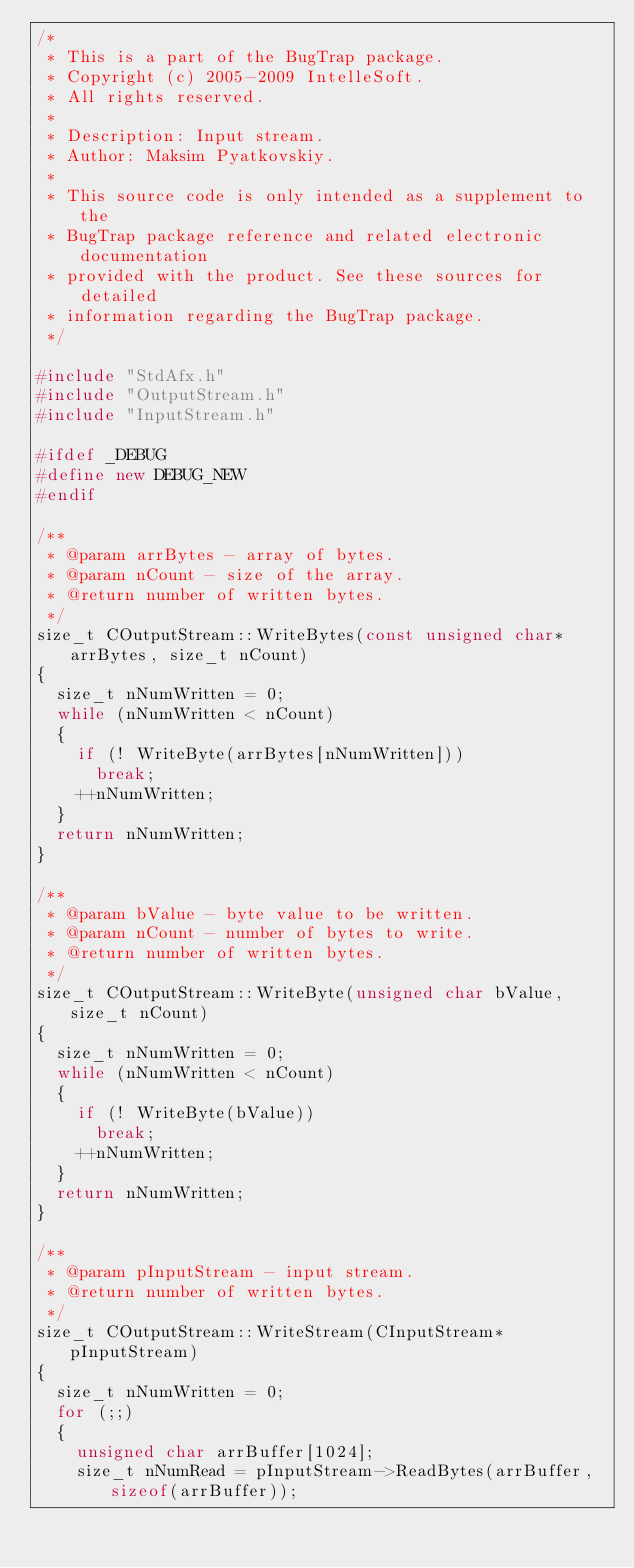Convert code to text. <code><loc_0><loc_0><loc_500><loc_500><_C++_>/*
 * This is a part of the BugTrap package.
 * Copyright (c) 2005-2009 IntelleSoft.
 * All rights reserved.
 *
 * Description: Input stream.
 * Author: Maksim Pyatkovskiy.
 *
 * This source code is only intended as a supplement to the
 * BugTrap package reference and related electronic documentation
 * provided with the product. See these sources for detailed
 * information regarding the BugTrap package.
 */

#include "StdAfx.h"
#include "OutputStream.h"
#include "InputStream.h"

#ifdef _DEBUG
#define new DEBUG_NEW
#endif

/**
 * @param arrBytes - array of bytes.
 * @param nCount - size of the array.
 * @return number of written bytes.
 */
size_t COutputStream::WriteBytes(const unsigned char* arrBytes, size_t nCount)
{
	size_t nNumWritten = 0;
	while (nNumWritten < nCount)
	{
		if (! WriteByte(arrBytes[nNumWritten]))
			break;
		++nNumWritten;
	}
	return nNumWritten;
}

/**
 * @param bValue - byte value to be written.
 * @param nCount - number of bytes to write.
 * @return number of written bytes.
 */
size_t COutputStream::WriteByte(unsigned char bValue, size_t nCount)
{
	size_t nNumWritten = 0;
	while (nNumWritten < nCount)
	{
		if (! WriteByte(bValue))
			break;
		++nNumWritten;
	}
	return nNumWritten;
}

/**
 * @param pInputStream - input stream.
 * @return number of written bytes.
 */
size_t COutputStream::WriteStream(CInputStream* pInputStream)
{
	size_t nNumWritten = 0;
	for (;;)
	{
		unsigned char arrBuffer[1024];
		size_t nNumRead = pInputStream->ReadBytes(arrBuffer, sizeof(arrBuffer));</code> 